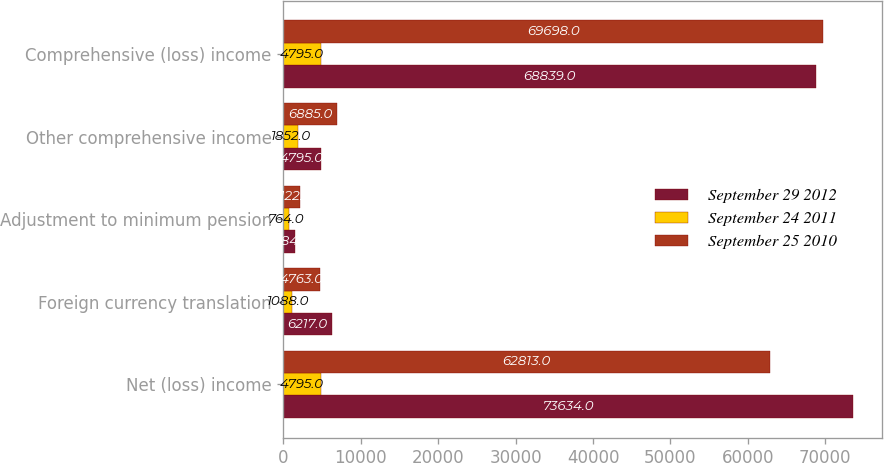Convert chart to OTSL. <chart><loc_0><loc_0><loc_500><loc_500><stacked_bar_chart><ecel><fcel>Net (loss) income<fcel>Foreign currency translation<fcel>Adjustment to minimum pension<fcel>Other comprehensive income<fcel>Comprehensive (loss) income<nl><fcel>September 29 2012<fcel>73634<fcel>6217<fcel>1484<fcel>4795<fcel>68839<nl><fcel>September 24 2011<fcel>4795<fcel>1088<fcel>764<fcel>1852<fcel>4795<nl><fcel>September 25 2010<fcel>62813<fcel>4763<fcel>2122<fcel>6885<fcel>69698<nl></chart> 